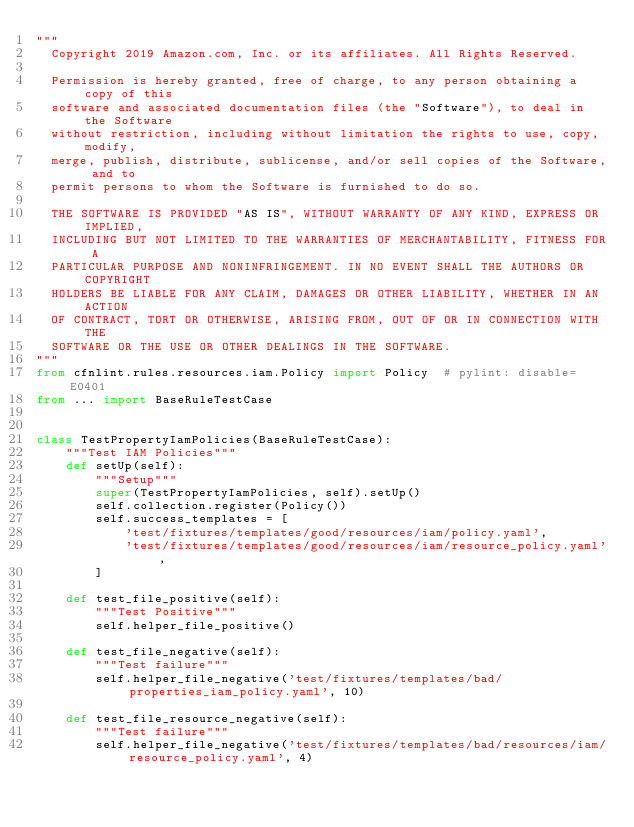<code> <loc_0><loc_0><loc_500><loc_500><_Python_>"""
  Copyright 2019 Amazon.com, Inc. or its affiliates. All Rights Reserved.

  Permission is hereby granted, free of charge, to any person obtaining a copy of this
  software and associated documentation files (the "Software"), to deal in the Software
  without restriction, including without limitation the rights to use, copy, modify,
  merge, publish, distribute, sublicense, and/or sell copies of the Software, and to
  permit persons to whom the Software is furnished to do so.

  THE SOFTWARE IS PROVIDED "AS IS", WITHOUT WARRANTY OF ANY KIND, EXPRESS OR IMPLIED,
  INCLUDING BUT NOT LIMITED TO THE WARRANTIES OF MERCHANTABILITY, FITNESS FOR A
  PARTICULAR PURPOSE AND NONINFRINGEMENT. IN NO EVENT SHALL THE AUTHORS OR COPYRIGHT
  HOLDERS BE LIABLE FOR ANY CLAIM, DAMAGES OR OTHER LIABILITY, WHETHER IN AN ACTION
  OF CONTRACT, TORT OR OTHERWISE, ARISING FROM, OUT OF OR IN CONNECTION WITH THE
  SOFTWARE OR THE USE OR OTHER DEALINGS IN THE SOFTWARE.
"""
from cfnlint.rules.resources.iam.Policy import Policy  # pylint: disable=E0401
from ... import BaseRuleTestCase


class TestPropertyIamPolicies(BaseRuleTestCase):
    """Test IAM Policies"""
    def setUp(self):
        """Setup"""
        super(TestPropertyIamPolicies, self).setUp()
        self.collection.register(Policy())
        self.success_templates = [
            'test/fixtures/templates/good/resources/iam/policy.yaml',
            'test/fixtures/templates/good/resources/iam/resource_policy.yaml',
        ]

    def test_file_positive(self):
        """Test Positive"""
        self.helper_file_positive()

    def test_file_negative(self):
        """Test failure"""
        self.helper_file_negative('test/fixtures/templates/bad/properties_iam_policy.yaml', 10)

    def test_file_resource_negative(self):
        """Test failure"""
        self.helper_file_negative('test/fixtures/templates/bad/resources/iam/resource_policy.yaml', 4)
</code> 